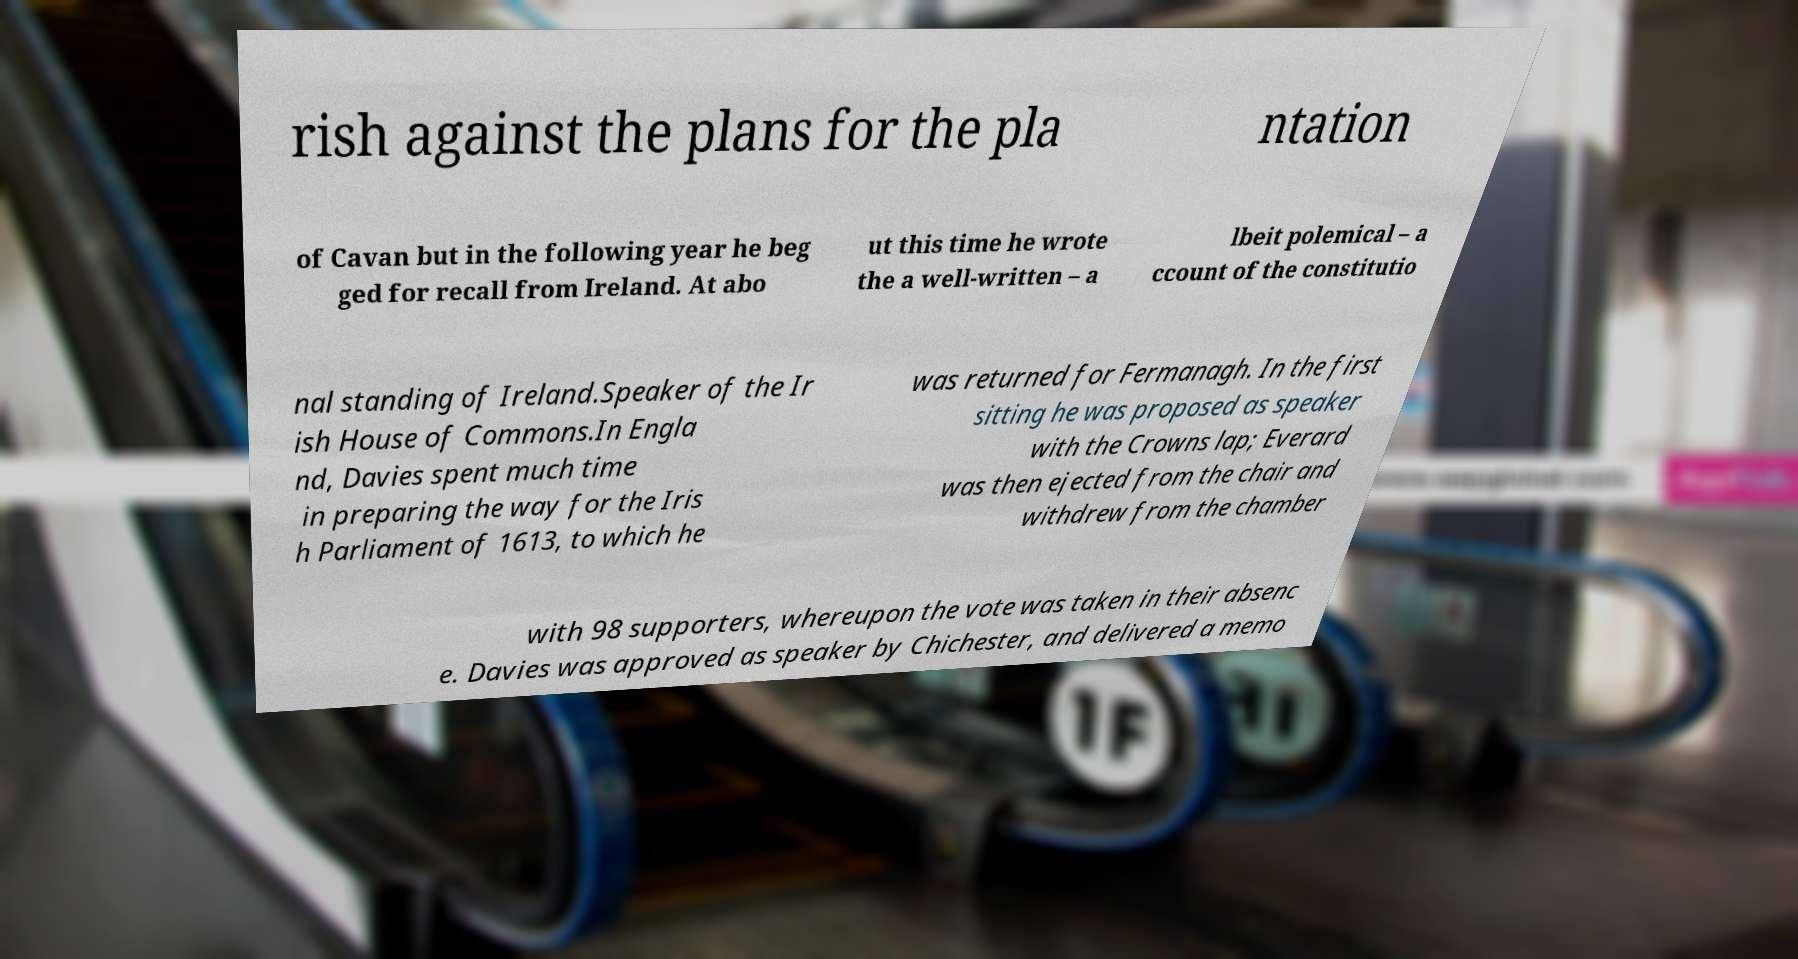For documentation purposes, I need the text within this image transcribed. Could you provide that? rish against the plans for the pla ntation of Cavan but in the following year he beg ged for recall from Ireland. At abo ut this time he wrote the a well-written – a lbeit polemical – a ccount of the constitutio nal standing of Ireland.Speaker of the Ir ish House of Commons.In Engla nd, Davies spent much time in preparing the way for the Iris h Parliament of 1613, to which he was returned for Fermanagh. In the first sitting he was proposed as speaker with the Crowns lap; Everard was then ejected from the chair and withdrew from the chamber with 98 supporters, whereupon the vote was taken in their absenc e. Davies was approved as speaker by Chichester, and delivered a memo 